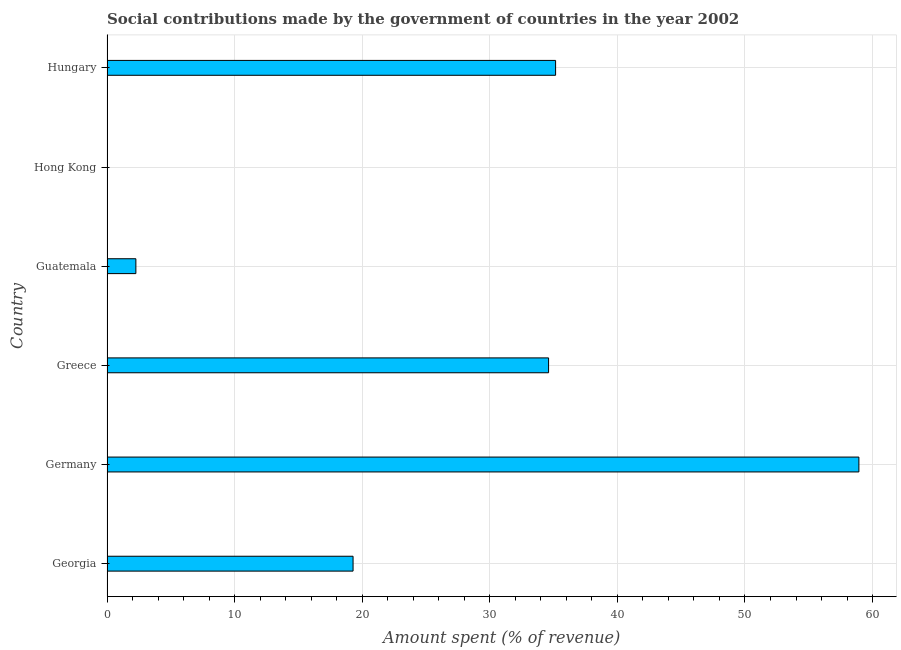Does the graph contain grids?
Keep it short and to the point. Yes. What is the title of the graph?
Keep it short and to the point. Social contributions made by the government of countries in the year 2002. What is the label or title of the X-axis?
Offer a terse response. Amount spent (% of revenue). What is the amount spent in making social contributions in Guatemala?
Offer a very short reply. 2.26. Across all countries, what is the maximum amount spent in making social contributions?
Your answer should be compact. 58.93. Across all countries, what is the minimum amount spent in making social contributions?
Provide a succinct answer. 0.01. In which country was the amount spent in making social contributions minimum?
Make the answer very short. Hong Kong. What is the sum of the amount spent in making social contributions?
Provide a succinct answer. 150.25. What is the difference between the amount spent in making social contributions in Georgia and Germany?
Provide a short and direct response. -39.64. What is the average amount spent in making social contributions per country?
Your answer should be very brief. 25.04. What is the median amount spent in making social contributions?
Your answer should be compact. 26.95. What is the ratio of the amount spent in making social contributions in Germany to that in Guatemala?
Your answer should be very brief. 26.05. Is the amount spent in making social contributions in Germany less than that in Guatemala?
Offer a very short reply. No. Is the difference between the amount spent in making social contributions in Georgia and Germany greater than the difference between any two countries?
Provide a short and direct response. No. What is the difference between the highest and the second highest amount spent in making social contributions?
Your answer should be very brief. 23.77. What is the difference between the highest and the lowest amount spent in making social contributions?
Provide a short and direct response. 58.91. How many bars are there?
Offer a terse response. 6. How many countries are there in the graph?
Ensure brevity in your answer.  6. What is the Amount spent (% of revenue) in Georgia?
Provide a short and direct response. 19.28. What is the Amount spent (% of revenue) in Germany?
Keep it short and to the point. 58.93. What is the Amount spent (% of revenue) in Greece?
Your response must be concise. 34.61. What is the Amount spent (% of revenue) of Guatemala?
Your answer should be compact. 2.26. What is the Amount spent (% of revenue) of Hong Kong?
Provide a succinct answer. 0.01. What is the Amount spent (% of revenue) in Hungary?
Ensure brevity in your answer.  35.16. What is the difference between the Amount spent (% of revenue) in Georgia and Germany?
Offer a very short reply. -39.64. What is the difference between the Amount spent (% of revenue) in Georgia and Greece?
Make the answer very short. -15.32. What is the difference between the Amount spent (% of revenue) in Georgia and Guatemala?
Give a very brief answer. 17.02. What is the difference between the Amount spent (% of revenue) in Georgia and Hong Kong?
Your answer should be compact. 19.27. What is the difference between the Amount spent (% of revenue) in Georgia and Hungary?
Offer a very short reply. -15.87. What is the difference between the Amount spent (% of revenue) in Germany and Greece?
Provide a short and direct response. 24.32. What is the difference between the Amount spent (% of revenue) in Germany and Guatemala?
Ensure brevity in your answer.  56.67. What is the difference between the Amount spent (% of revenue) in Germany and Hong Kong?
Provide a succinct answer. 58.91. What is the difference between the Amount spent (% of revenue) in Germany and Hungary?
Your response must be concise. 23.77. What is the difference between the Amount spent (% of revenue) in Greece and Guatemala?
Keep it short and to the point. 32.35. What is the difference between the Amount spent (% of revenue) in Greece and Hong Kong?
Offer a very short reply. 34.59. What is the difference between the Amount spent (% of revenue) in Greece and Hungary?
Offer a terse response. -0.55. What is the difference between the Amount spent (% of revenue) in Guatemala and Hong Kong?
Your response must be concise. 2.25. What is the difference between the Amount spent (% of revenue) in Guatemala and Hungary?
Make the answer very short. -32.9. What is the difference between the Amount spent (% of revenue) in Hong Kong and Hungary?
Give a very brief answer. -35.14. What is the ratio of the Amount spent (% of revenue) in Georgia to that in Germany?
Ensure brevity in your answer.  0.33. What is the ratio of the Amount spent (% of revenue) in Georgia to that in Greece?
Offer a very short reply. 0.56. What is the ratio of the Amount spent (% of revenue) in Georgia to that in Guatemala?
Provide a short and direct response. 8.53. What is the ratio of the Amount spent (% of revenue) in Georgia to that in Hong Kong?
Provide a succinct answer. 1413.23. What is the ratio of the Amount spent (% of revenue) in Georgia to that in Hungary?
Make the answer very short. 0.55. What is the ratio of the Amount spent (% of revenue) in Germany to that in Greece?
Ensure brevity in your answer.  1.7. What is the ratio of the Amount spent (% of revenue) in Germany to that in Guatemala?
Ensure brevity in your answer.  26.05. What is the ratio of the Amount spent (% of revenue) in Germany to that in Hong Kong?
Provide a short and direct response. 4318.37. What is the ratio of the Amount spent (% of revenue) in Germany to that in Hungary?
Your answer should be very brief. 1.68. What is the ratio of the Amount spent (% of revenue) in Greece to that in Guatemala?
Ensure brevity in your answer.  15.3. What is the ratio of the Amount spent (% of revenue) in Greece to that in Hong Kong?
Provide a succinct answer. 2536.15. What is the ratio of the Amount spent (% of revenue) in Greece to that in Hungary?
Give a very brief answer. 0.98. What is the ratio of the Amount spent (% of revenue) in Guatemala to that in Hong Kong?
Your answer should be compact. 165.78. What is the ratio of the Amount spent (% of revenue) in Guatemala to that in Hungary?
Offer a terse response. 0.06. What is the ratio of the Amount spent (% of revenue) in Hong Kong to that in Hungary?
Your answer should be compact. 0. 